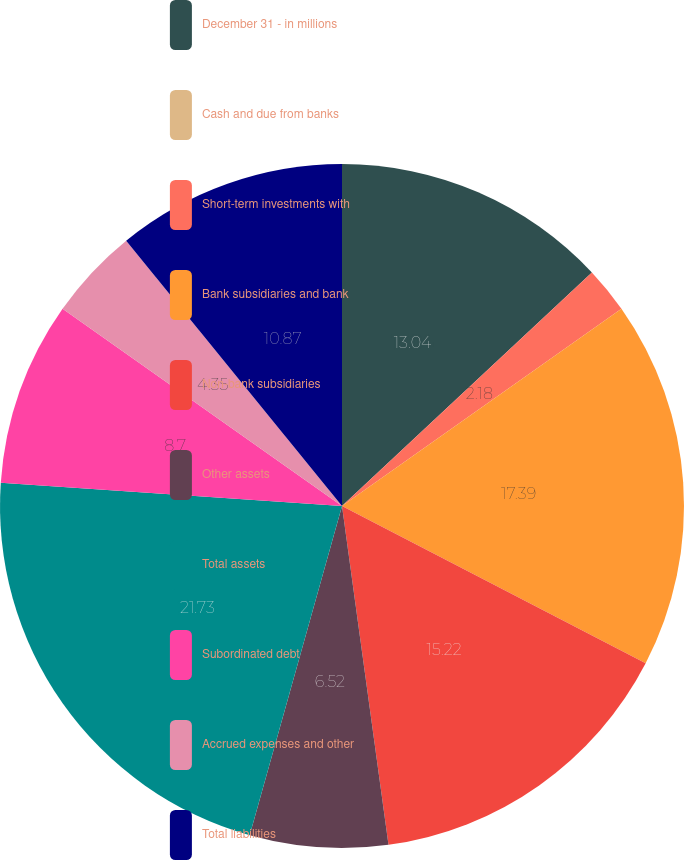Convert chart. <chart><loc_0><loc_0><loc_500><loc_500><pie_chart><fcel>December 31 - in millions<fcel>Cash and due from banks<fcel>Short-term investments with<fcel>Bank subsidiaries and bank<fcel>Non-bank subsidiaries<fcel>Other assets<fcel>Total assets<fcel>Subordinated debt<fcel>Accrued expenses and other<fcel>Total liabilities<nl><fcel>13.04%<fcel>0.0%<fcel>2.18%<fcel>17.39%<fcel>15.22%<fcel>6.52%<fcel>21.73%<fcel>8.7%<fcel>4.35%<fcel>10.87%<nl></chart> 